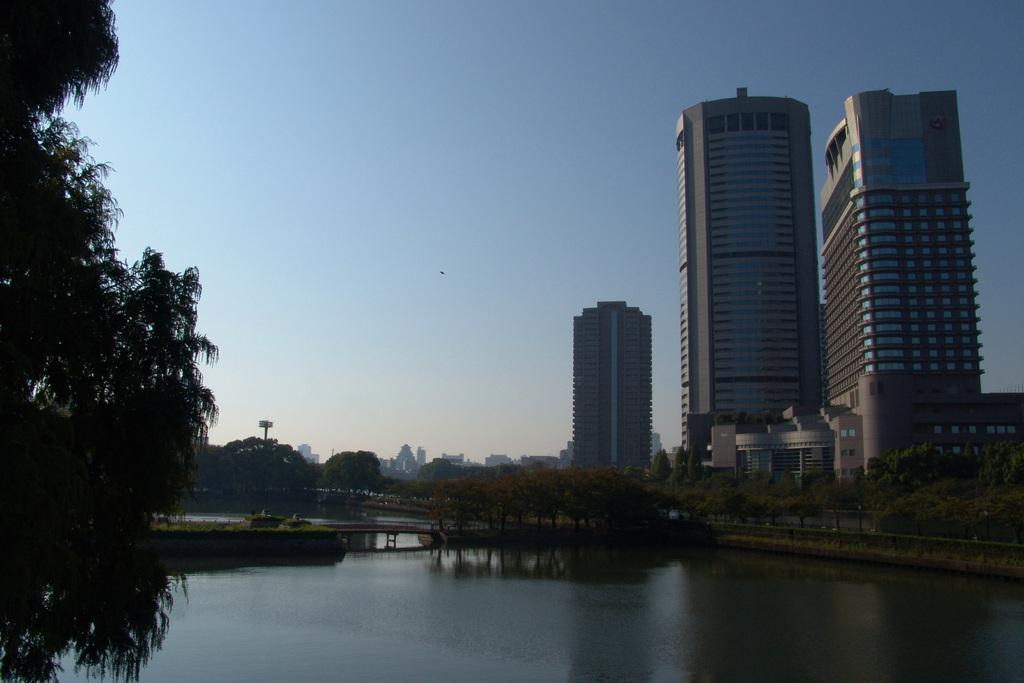What is at the bottom of the image? There is water at the bottom of the image. What can be seen in the background of the image? There are buildings, trees, and the sky visible in the background of the image. What is the main structure in the image? There is a bridge in the image. Where is the bridge located in the image? The bridge is located to the left side of the image. How many people are resting in the crowd in the image? There is no crowd or people resting in the image; it features water, buildings, trees, sky, and a bridge. What word is written on the bridge in the image? There is no word written on the bridge in the image; it is a structure connecting two areas. 